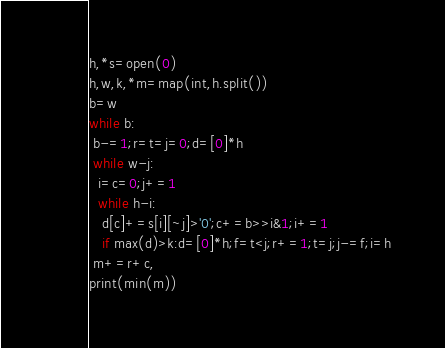Convert code to text. <code><loc_0><loc_0><loc_500><loc_500><_Python_>h,*s=open(0)
h,w,k,*m=map(int,h.split())
b=w
while b:
 b-=1;r=t=j=0;d=[0]*h
 while w-j:
  i=c=0;j+=1
  while h-i:
   d[c]+=s[i][~j]>'0';c+=b>>i&1;i+=1
   if max(d)>k:d=[0]*h;f=t<j;r+=1;t=j;j-=f;i=h
 m+=r+c,
print(min(m))</code> 